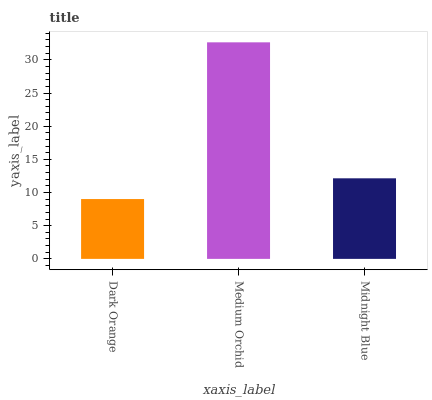Is Midnight Blue the minimum?
Answer yes or no. No. Is Midnight Blue the maximum?
Answer yes or no. No. Is Medium Orchid greater than Midnight Blue?
Answer yes or no. Yes. Is Midnight Blue less than Medium Orchid?
Answer yes or no. Yes. Is Midnight Blue greater than Medium Orchid?
Answer yes or no. No. Is Medium Orchid less than Midnight Blue?
Answer yes or no. No. Is Midnight Blue the high median?
Answer yes or no. Yes. Is Midnight Blue the low median?
Answer yes or no. Yes. Is Dark Orange the high median?
Answer yes or no. No. Is Dark Orange the low median?
Answer yes or no. No. 